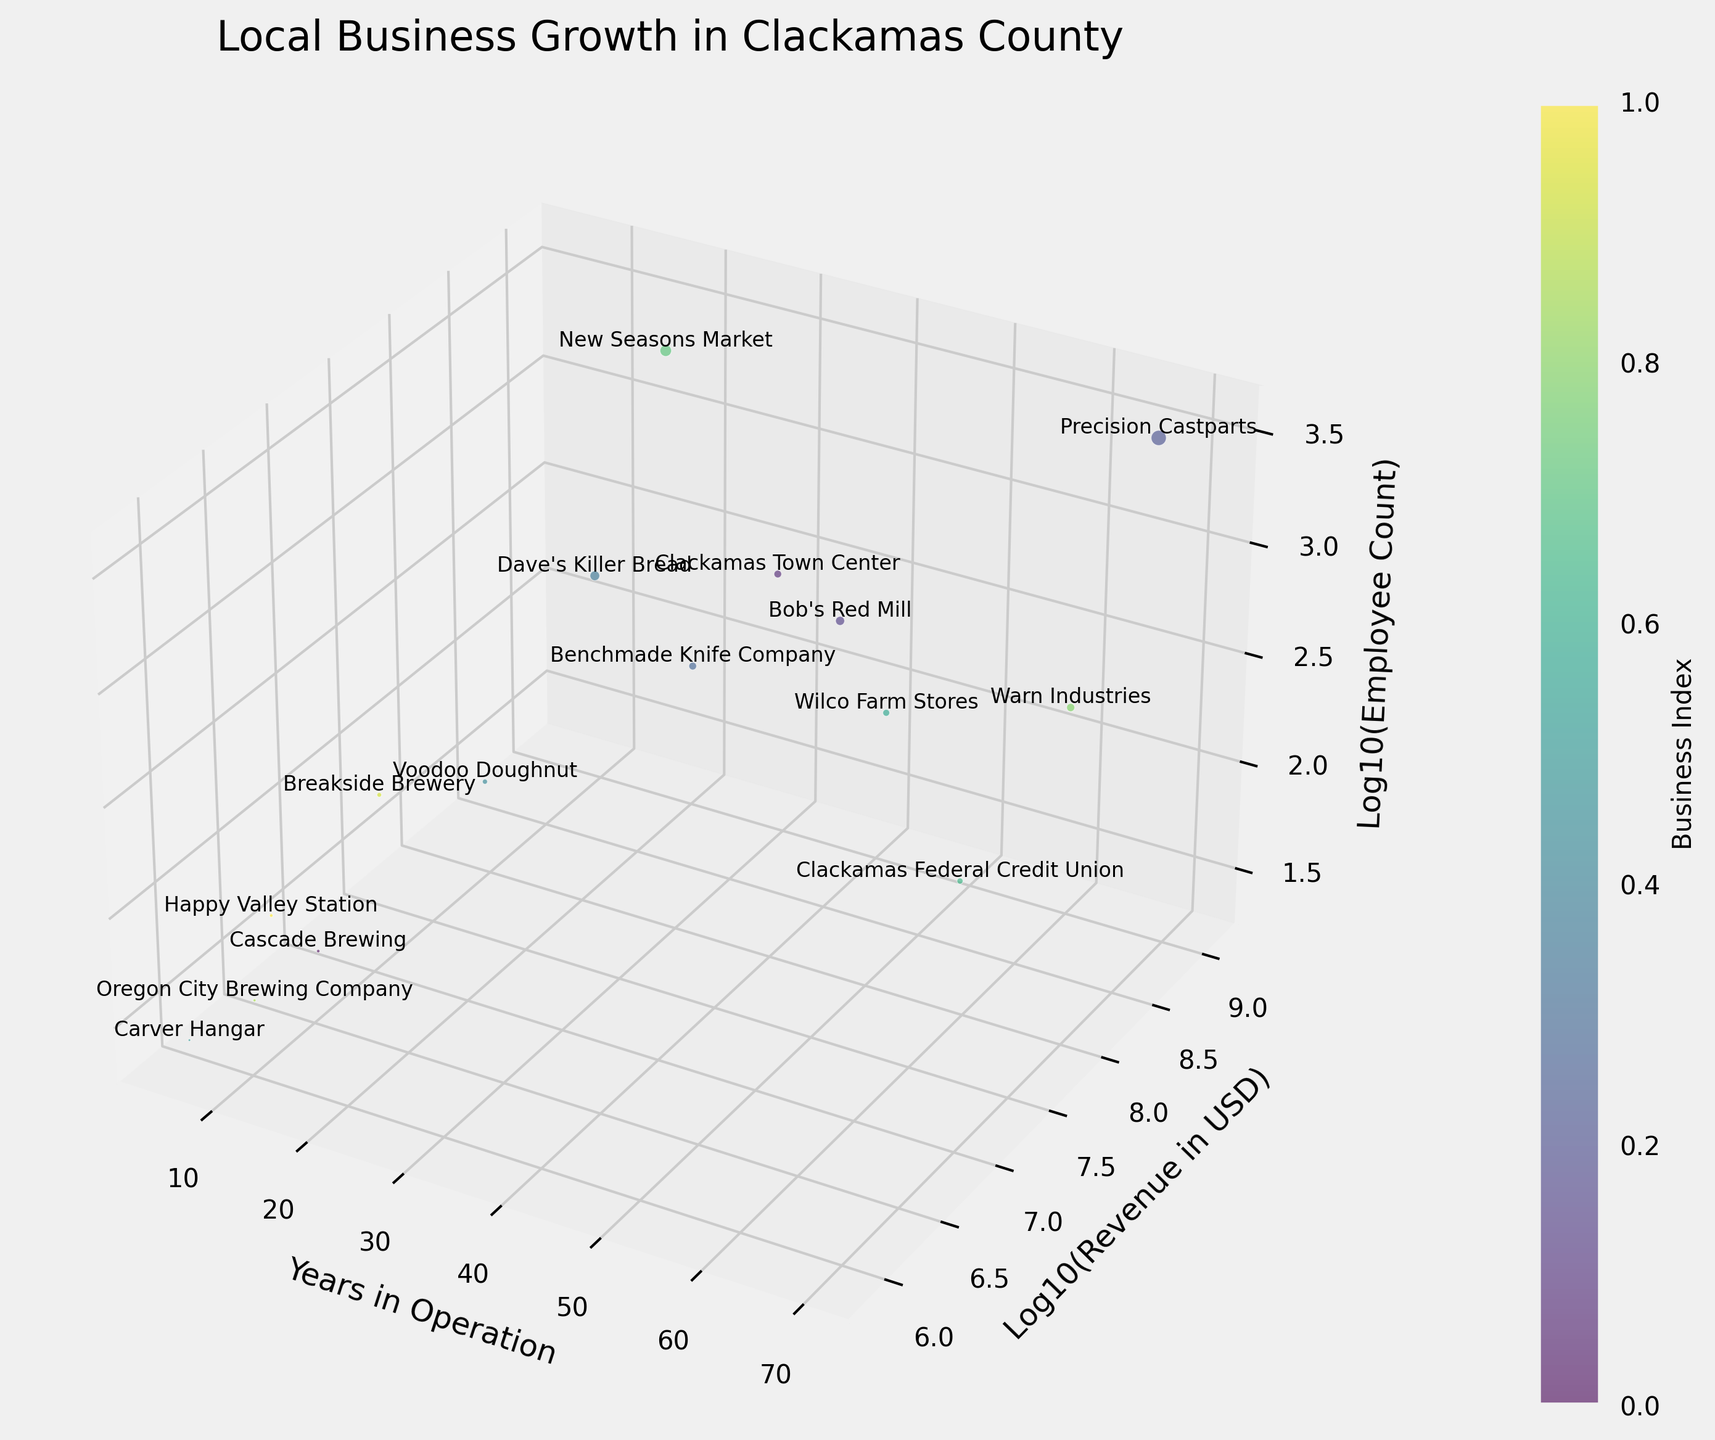What is the title of the figure? The title is commonly placed at the top of the chart to provide a brief description of what the figure is about. In this case, it is "Local Business Growth in Clackamas County."
Answer: Local Business Growth in Clackamas County What does the x-axis represent in this figure? The label on the x-axis indicates what data dimension it represents. Here, it stands for "Years in Operation," indicating how long each business has been operating.
Answer: Years in Operation Which business has the highest revenue according to the figure? By examining the log10(revenue) values on the y-axis, the business with the highest bubble along the y-axis will have the highest revenue. This is "Precision Castparts" with the highest y-axis value.
Answer: Precision Castparts How many businesses have been in operation for more than 50 years? Count the number of bubbles positioned to the right of the 50-year mark on the x-axis. There are two such businesses: "Precision Castparts" and "Wilco Farm Stores."
Answer: 2 Which business has the smallest bubble size and what does it indicate? The smallest bubble size can be identified visually. This corresponds to "Carver Hangar," indicating it has the smallest revenue since bubble size is related to revenue.
Answer: Carver Hangar Which business has the highest employee count? By looking at the log10(employee count) on the z-axis, the business with the highest value on this axis will have the highest employee count. This is "New Seasons Market" with the highest z-axis value.
Answer: New Seasons Market How do the revenue and employee count of New Seasons Market compare to those of Dave's Killer Bread? Check the y and z positions in the figure for both businesses. New Seasons Market has a higher log10(revenue) and log10(employee count) compared to Dave's Killer Bread, indicating it has both higher revenue and a higher employee count.
Answer: New Seasons Market has higher revenue and employee count Calculate the average log10(revenue) for businesses that have been operating for more than 20 years. Identify businesses with more than 20 years in operation, sum up their log10(revenue) values, and divide by the number of such businesses. These businesses are "Clackamas Town Center," "Bob's Red Mill," "Precision Castparts," "Benchmade Knife Company," "Wilco Farm Stores," "Clackamas Federal Credit Union," and "New Seasons Market."
Answer: Average is approximately 7.730 Which business with less than 10 years in operation has the highest log10(employee count)? Focus on businesses with less than 10 years in operation and compare their log10(employee count). "Happy Valley Station" is identified as the one with the highest log10(employee count) in this subset.
Answer: Happy Valley Station 